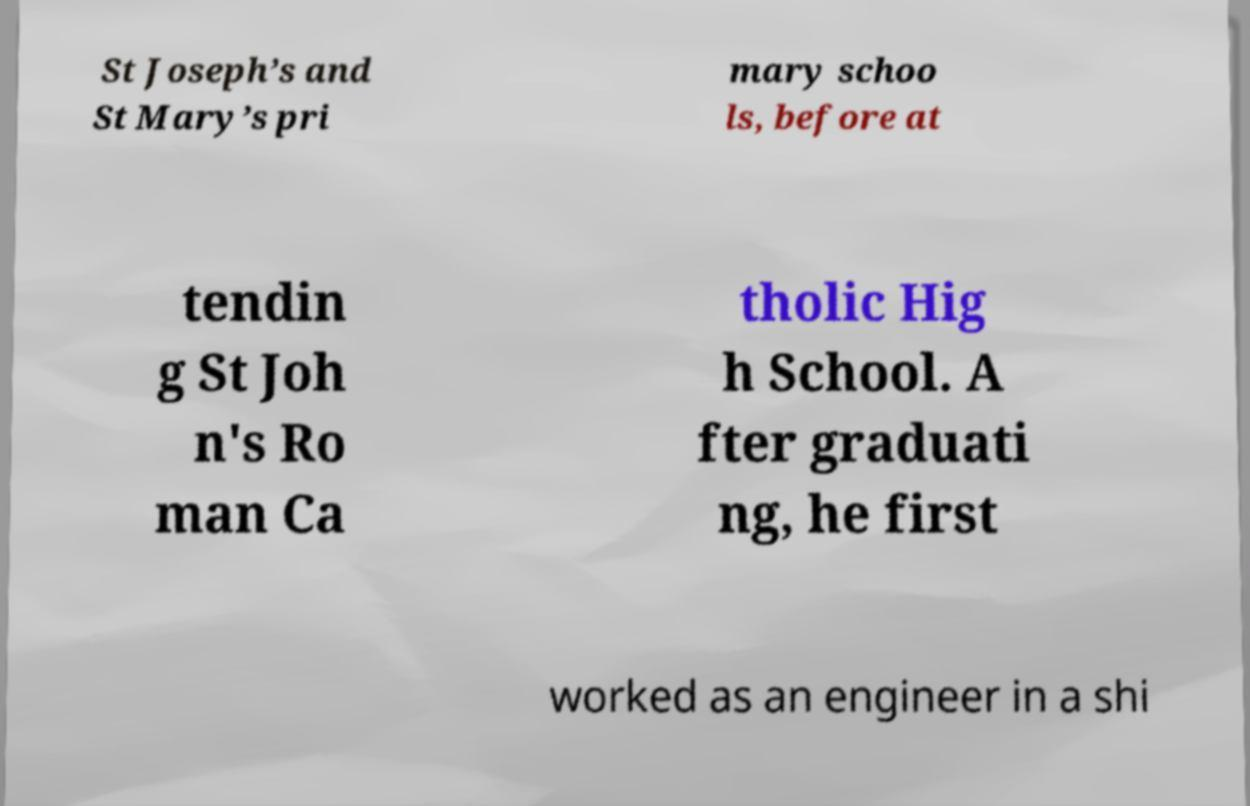Could you assist in decoding the text presented in this image and type it out clearly? St Joseph’s and St Mary’s pri mary schoo ls, before at tendin g St Joh n's Ro man Ca tholic Hig h School. A fter graduati ng, he first worked as an engineer in a shi 